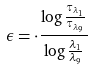<formula> <loc_0><loc_0><loc_500><loc_500>\epsilon = \cdot \frac { \log \frac { \tau _ { \lambda _ { 1 } } } { \tau _ { \lambda _ { 9 } } } } { \log \frac { \lambda _ { 1 } } { \lambda _ { 9 } } }</formula> 